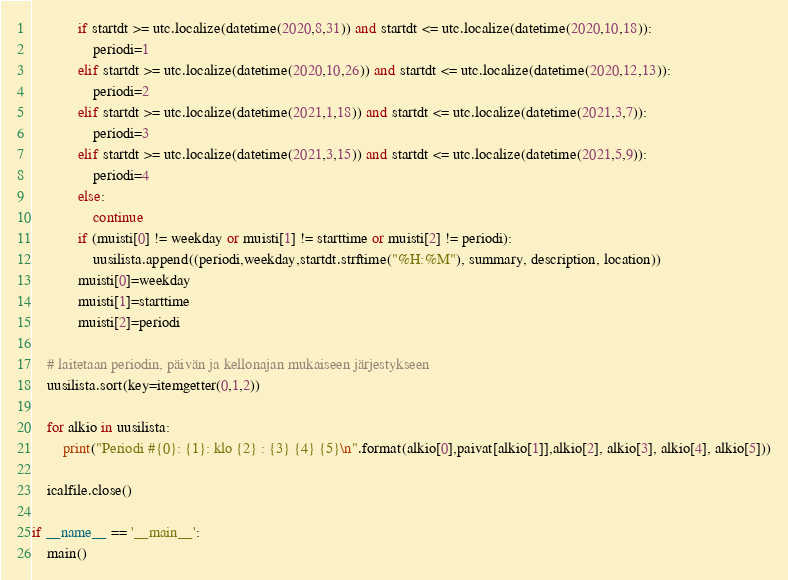Convert code to text. <code><loc_0><loc_0><loc_500><loc_500><_Python_>
            if startdt >= utc.localize(datetime(2020,8,31)) and startdt <= utc.localize(datetime(2020,10,18)):
                periodi=1
            elif startdt >= utc.localize(datetime(2020,10,26)) and startdt <= utc.localize(datetime(2020,12,13)):
                periodi=2
            elif startdt >= utc.localize(datetime(2021,1,18)) and startdt <= utc.localize(datetime(2021,3,7)):
                periodi=3
            elif startdt >= utc.localize(datetime(2021,3,15)) and startdt <= utc.localize(datetime(2021,5,9)):
                periodi=4
            else:
                continue
            if (muisti[0] != weekday or muisti[1] != starttime or muisti[2] != periodi):
                uusilista.append((periodi,weekday,startdt.strftime("%H:%M"), summary, description, location))
            muisti[0]=weekday
            muisti[1]=starttime
            muisti[2]=periodi

    # laitetaan periodin, päivän ja kellonajan mukaiseen järjestykseen
    uusilista.sort(key=itemgetter(0,1,2))

    for alkio in uusilista:
        print("Periodi #{0}: {1}: klo {2} : {3} {4} {5}\n".format(alkio[0],paivat[alkio[1]],alkio[2], alkio[3], alkio[4], alkio[5]))

    icalfile.close()

if __name__ == '__main__':
    main()
</code> 